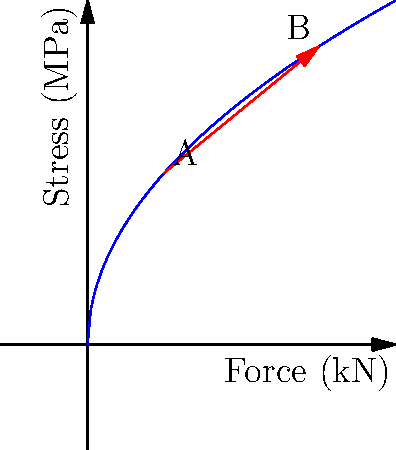In a car frame stress analysis for frontal collisions, the graph shows the relationship between applied force and resulting stress. If the stress at point A is 11.18 MPa, what is the approximate stress at point B? How does this relate to the car's safety design for accident victims? To solve this problem, we'll follow these steps:

1. Identify the relationship between force and stress:
   The curve suggests a non-linear relationship, specifically a square root function.

2. Determine the equation:
   The general form is $\sigma = k\sqrt{F}$, where $\sigma$ is stress and $F$ is force.

3. Calculate the constant $k$ using point A:
   At A, $F = 5$ kN and $\sigma = 11.18$ MPa
   $11.18 = k\sqrt{5}$
   $k = 11.18 / \sqrt{5} = 5$

4. Verify the equation:
   $\sigma = 5\sqrt{F}$

5. Calculate stress at point B:
   At B, $F = 15$ kN
   $\sigma_B = 5\sqrt{15} = 19.36$ MPa

6. Relation to car safety design:
   This non-linear relationship shows that stress doesn't increase proportionally with force. The car frame is designed to absorb more energy as the impact force increases, providing better protection for occupants in severe collisions. This is crucial for minimizing injuries to accident victims.
Answer: 19.36 MPa; non-linear stress increase enhances occupant protection in severe collisions. 